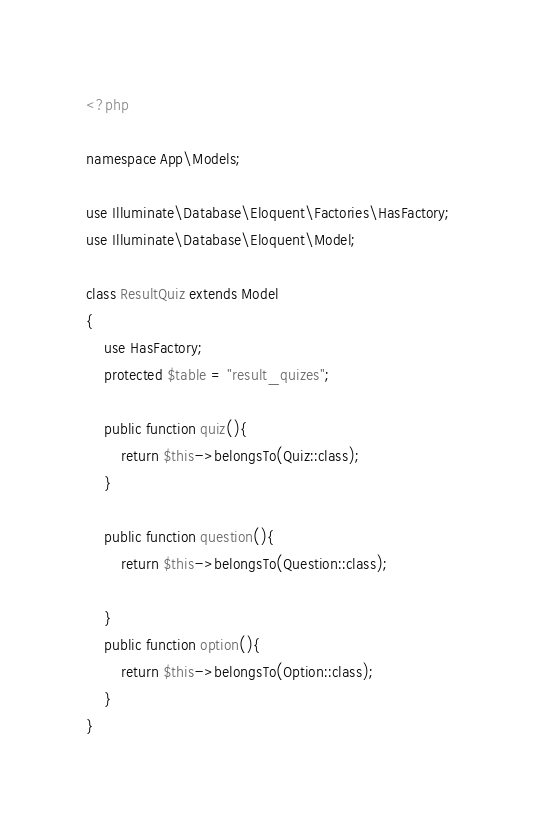<code> <loc_0><loc_0><loc_500><loc_500><_PHP_><?php

namespace App\Models;

use Illuminate\Database\Eloquent\Factories\HasFactory;
use Illuminate\Database\Eloquent\Model;

class ResultQuiz extends Model
{
    use HasFactory;
    protected $table = "result_quizes";

    public function quiz(){
        return $this->belongsTo(Quiz::class);
    }

    public function question(){
        return $this->belongsTo(Question::class);

    }
    public function option(){
        return $this->belongsTo(Option::class);
    }
}
</code> 